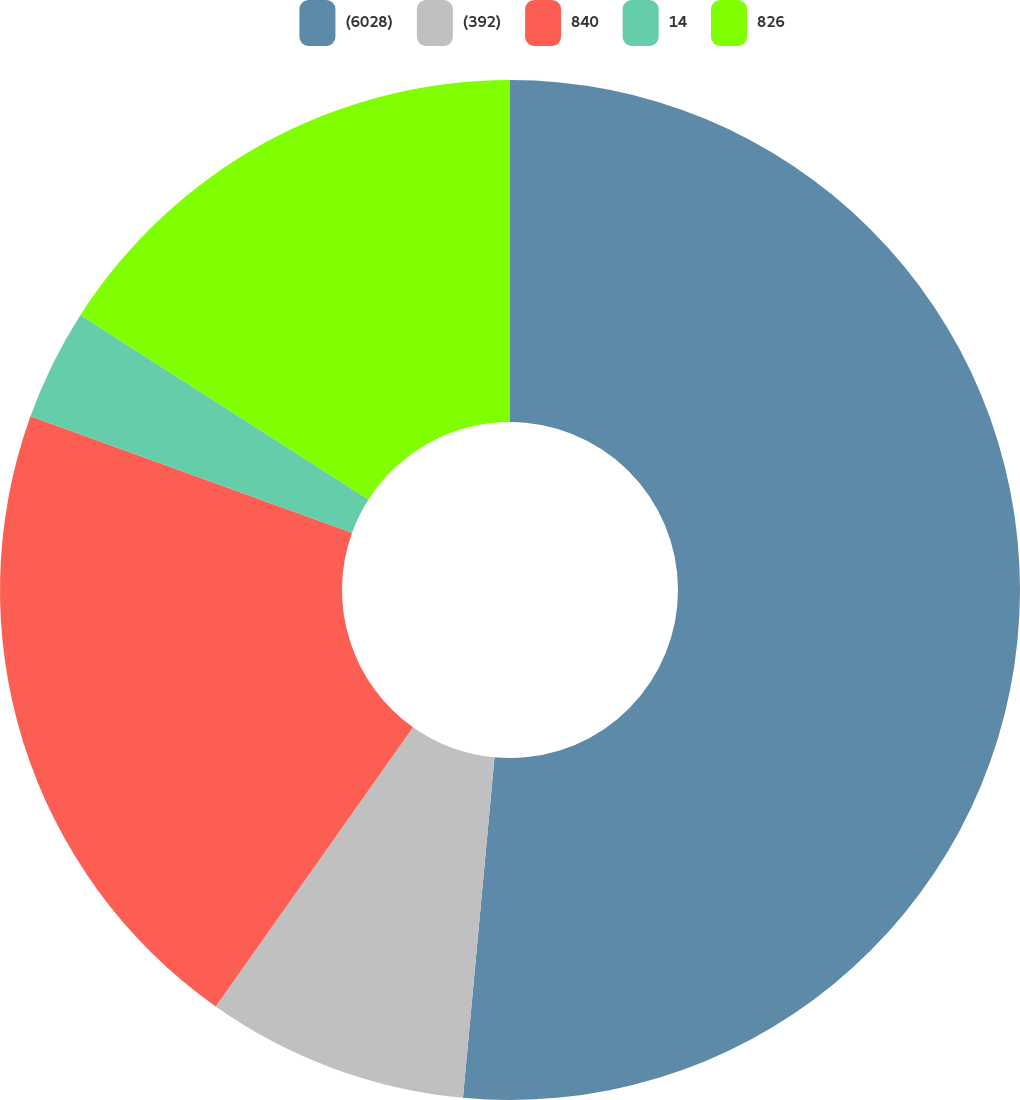Convert chart to OTSL. <chart><loc_0><loc_0><loc_500><loc_500><pie_chart><fcel>(6028)<fcel>(392)<fcel>840<fcel>14<fcel>826<nl><fcel>51.47%<fcel>8.32%<fcel>20.74%<fcel>3.53%<fcel>15.94%<nl></chart> 